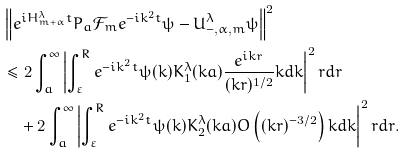<formula> <loc_0><loc_0><loc_500><loc_500>& \left \| e ^ { i H _ { m + \alpha } ^ { \lambda } t } P _ { a } \mathcal { F } _ { m } e ^ { - i k ^ { 2 } t } \psi - U _ { - , \alpha , m } ^ { \lambda } \psi \right \| ^ { 2 } \\ & \leq 2 \int _ { a } ^ { \infty } \left | \int _ { \varepsilon } ^ { R } e ^ { - i k ^ { 2 } t } \psi ( k ) K _ { 1 } ^ { \lambda } ( k a ) \frac { e ^ { i k r } } { ( k r ) ^ { 1 / 2 } } k d k \right | ^ { 2 } r d r \\ & \quad + 2 \int _ { a } ^ { \infty } \left | \int _ { \varepsilon } ^ { R } e ^ { - i k ^ { 2 } t } \psi ( k ) K _ { 2 } ^ { \lambda } ( k a ) O \left ( ( k r ) ^ { - 3 / 2 } \right ) k d k \right | ^ { 2 } r d r .</formula> 